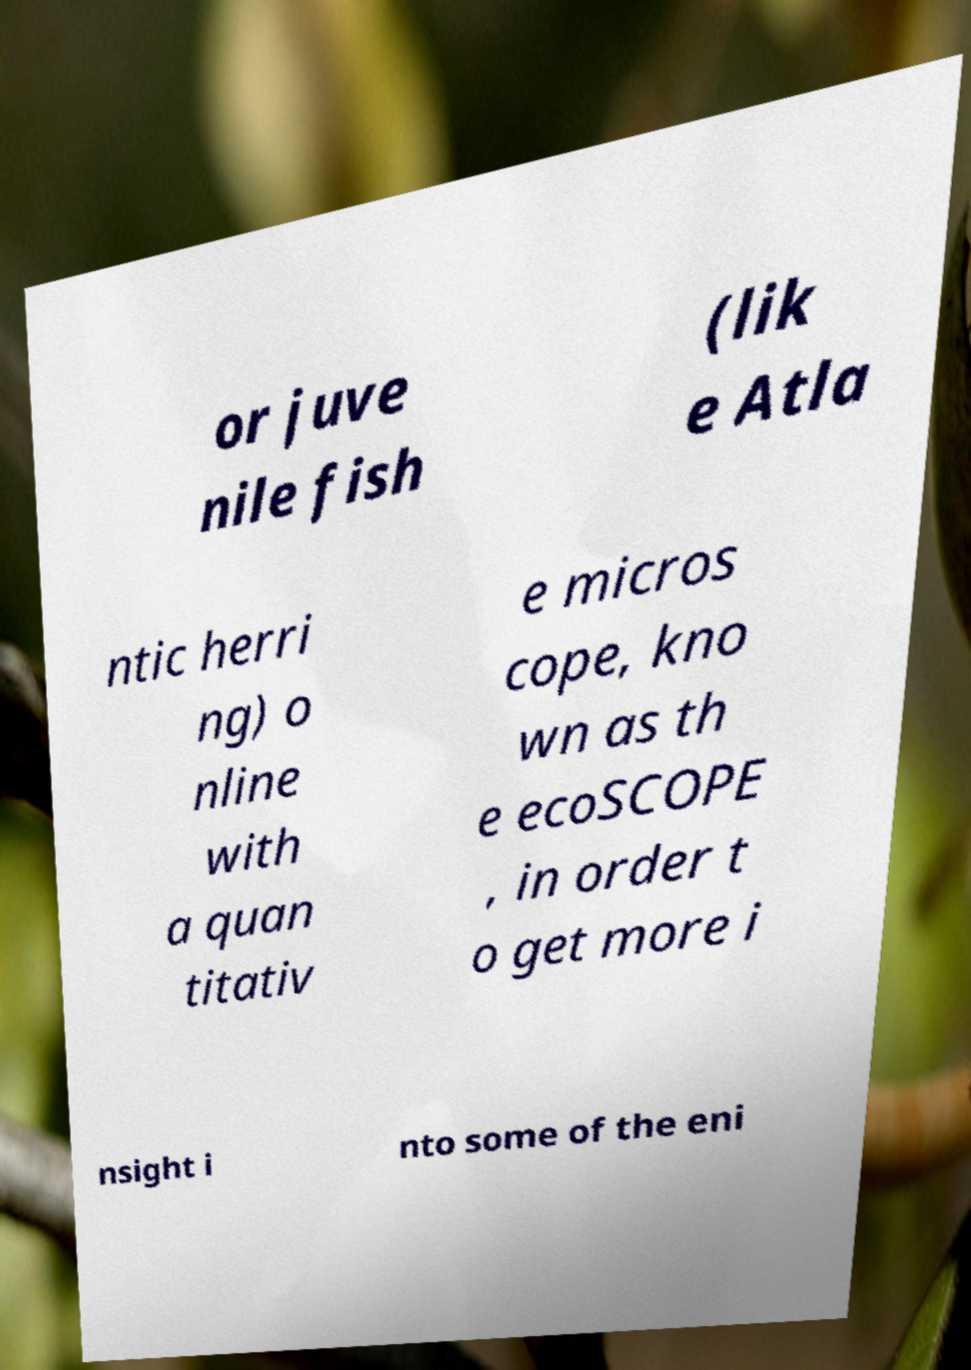I need the written content from this picture converted into text. Can you do that? or juve nile fish (lik e Atla ntic herri ng) o nline with a quan titativ e micros cope, kno wn as th e ecoSCOPE , in order t o get more i nsight i nto some of the eni 